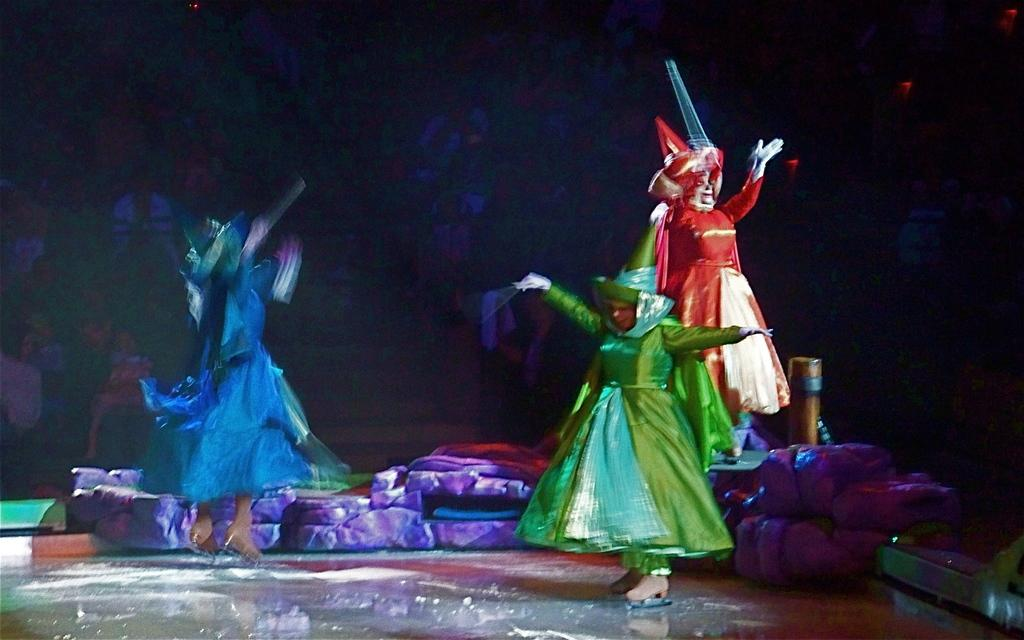How many people are in the image? There are three persons in the image. What are the persons wearing? The persons are wearing fancy dress. What can be seen beside the persons? There are objects beside the persons. What is visible in the background of the image? There is an audience in the background of the image. What type of sheet is being used by the father in the image? There is no father present in the image, and no sheet is visible. 